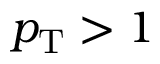Convert formula to latex. <formula><loc_0><loc_0><loc_500><loc_500>p _ { T } > 1</formula> 